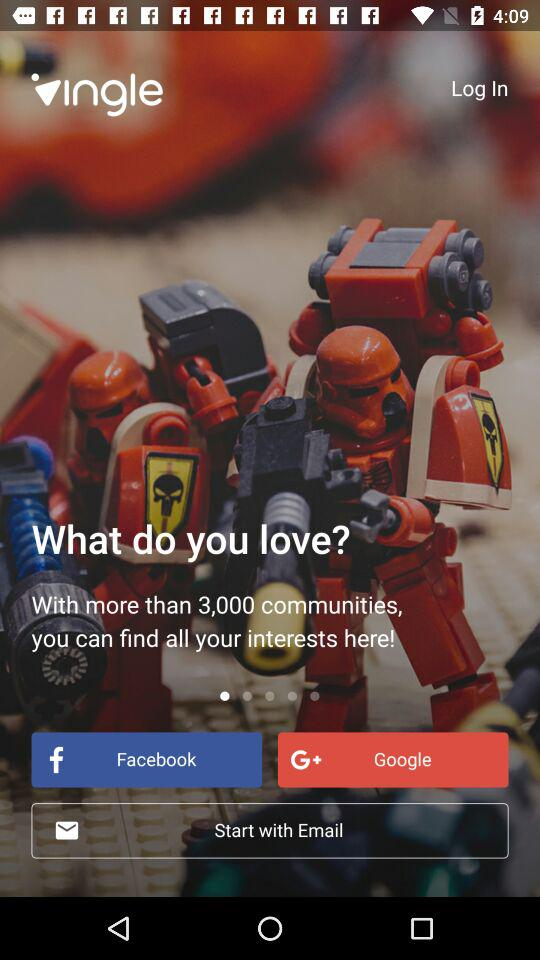With how many communities can the user find the interest? The user can find the interest with more than 3,000 communities. 